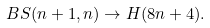Convert formula to latex. <formula><loc_0><loc_0><loc_500><loc_500>B S ( n + 1 , n ) \to H ( 8 n + 4 ) .</formula> 